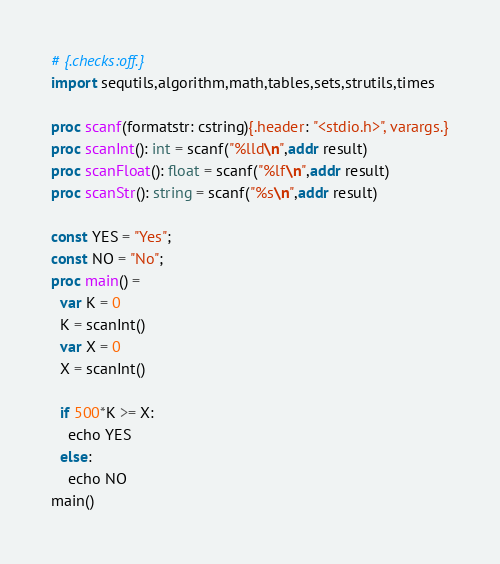<code> <loc_0><loc_0><loc_500><loc_500><_Nim_># {.checks:off.}
import sequtils,algorithm,math,tables,sets,strutils,times

proc scanf(formatstr: cstring){.header: "<stdio.h>", varargs.}
proc scanInt(): int = scanf("%lld\n",addr result)
proc scanFloat(): float = scanf("%lf\n",addr result)
proc scanStr(): string = scanf("%s\n",addr result)

const YES = "Yes";
const NO = "No";
proc main() =
  var K = 0
  K = scanInt()
  var X = 0
  X = scanInt()

  if 500*K >= X:
    echo YES
  else:
    echo NO
main()
</code> 